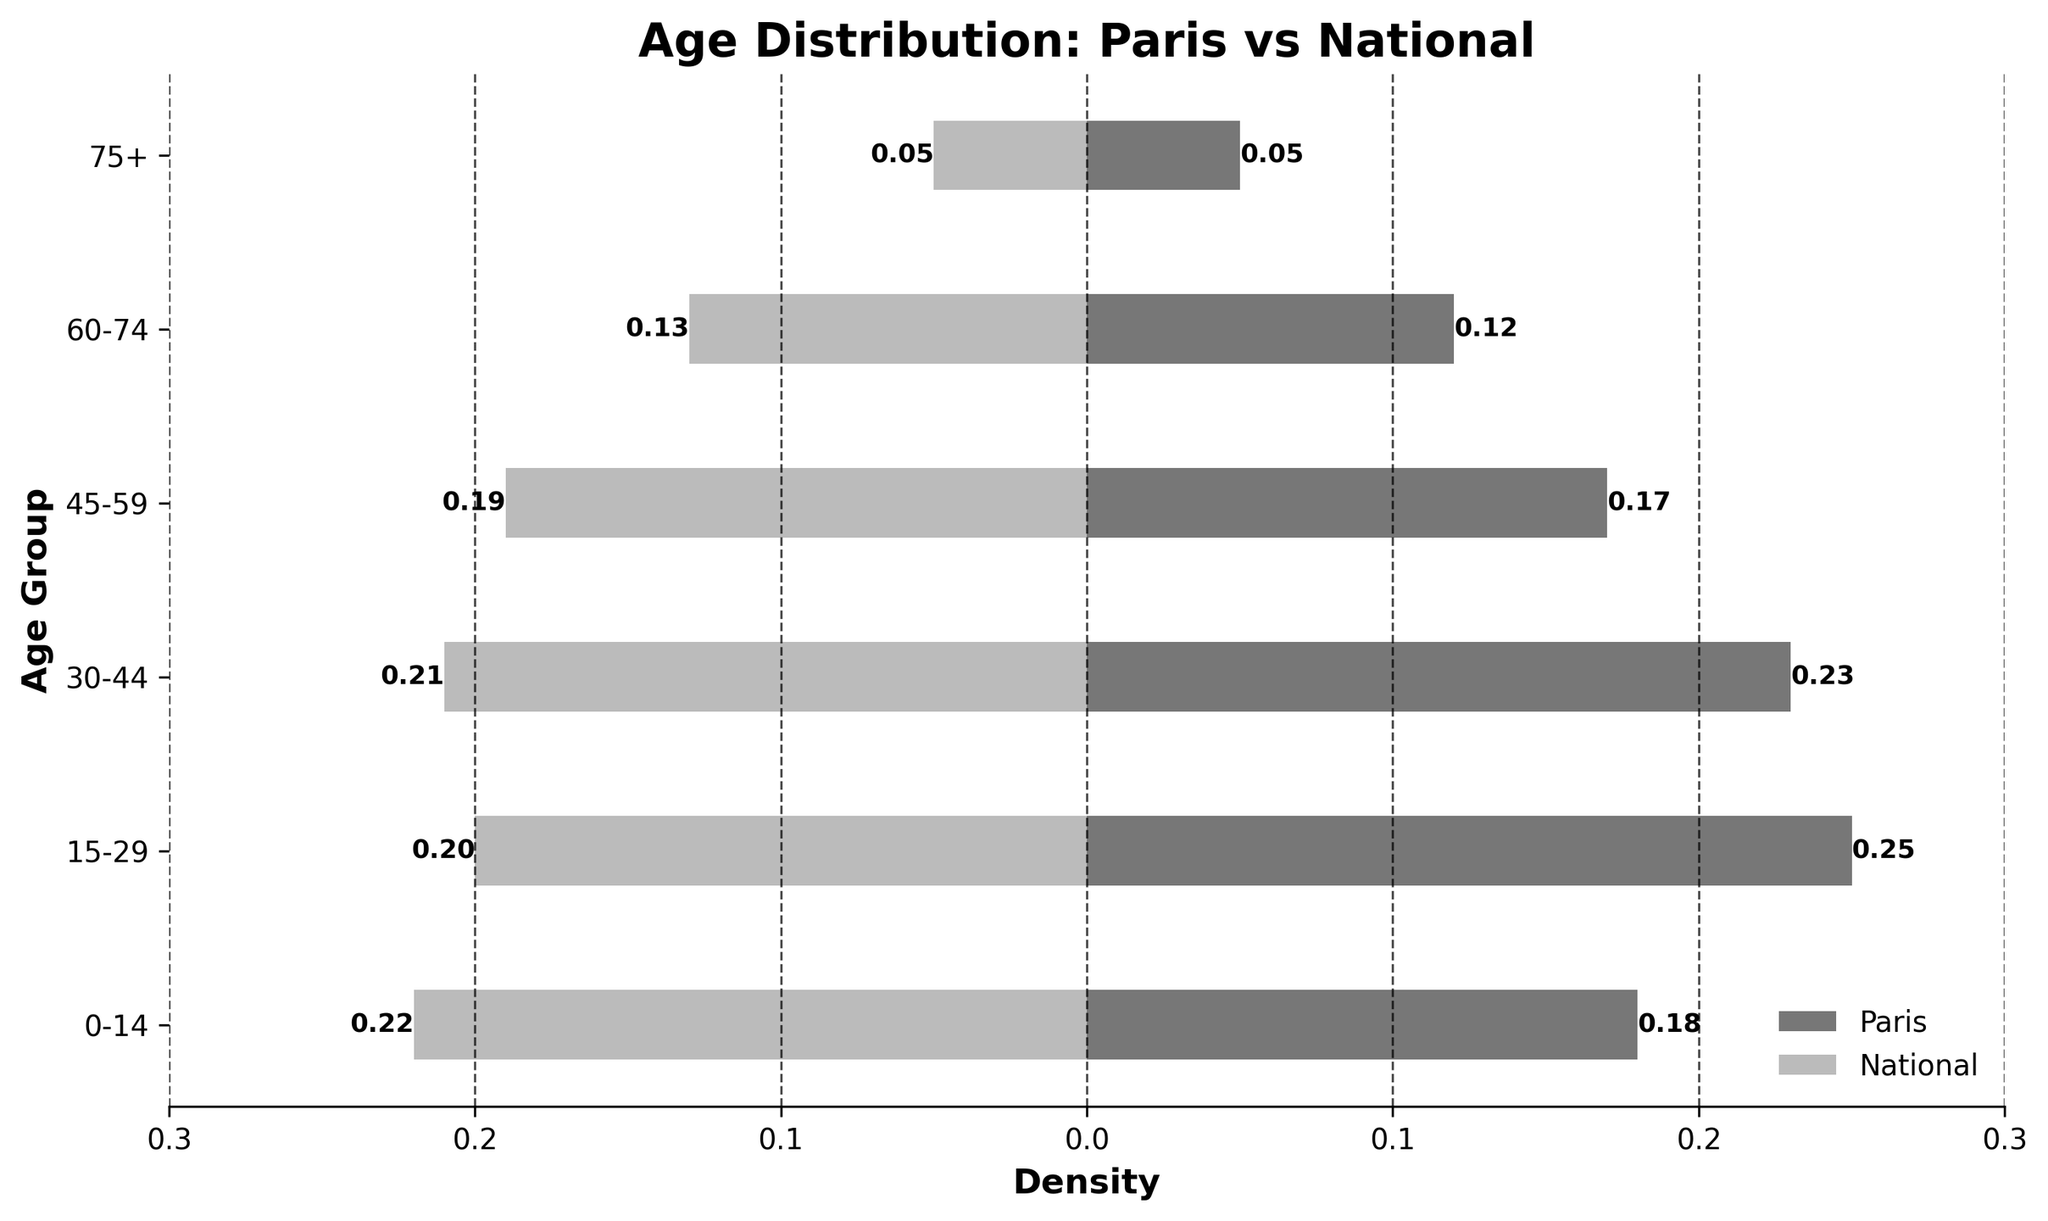What's the title of the figure? The title is positioned at the top of the figure in bold text. It reads 'Age Distribution: Paris vs National'.
Answer: Age Distribution: Paris vs National What are the age groups represented in this figure? The age groups are listed on the vertical axis, ranging from '0-14' to '75+'. They represent different segments of the population by age range.
Answer: 0-14, 15-29, 30-44, 45-59, 60-74, 75+ Which age group has the highest density in Paris? By looking at the horizontal bars extending from the left, the age group '15-29' has the longest bar representing a density of 0.25, which is the highest.
Answer: 15-29 How does the density of the '60-74' age group in Paris compare to the national density? Comparing the lengths of the bars for the '60-74' age group, the density in Paris (0.12) is slightly lower than the national density (0.13) as indicated by the shorter bar on the left.
Answer: Lower in Paris For which age group is the difference in density the greatest between Paris and the national average? The greatest difference appears between the two longest bars, which are for the '15-29' age group. Paris has a density of 0.25, while the national density is 0.20, showing a difference of 0.05.
Answer: 15-29 What is the total density of the age groups 0-14 and 15-29 in Paris? Adding the densities for the '0-14' (0.18) and '15-29' (0.25) age groups gives 0.18 + 0.25 = 0.43.
Answer: 0.43 In which age groups does Paris have a higher density than the national average? Comparing the lengths of the bars for each age group, Paris has higher densities in the '15-29' and '30-44' age groups.
Answer: 15-29, 30-44 Does the '75+' age group have the same density in Paris as the national average? Both the Paris and national average bars for the '75+' age group are of equal length, representing a density of 0.05.
Answer: Yes What is the difference in density between the '0-14' and '45-59' age groups in Paris? Subtracting the density of '45-59' (0.17) from the density of '0-14' (0.18) gives 0.18 - 0.17 = 0.01.
Answer: 0.01 